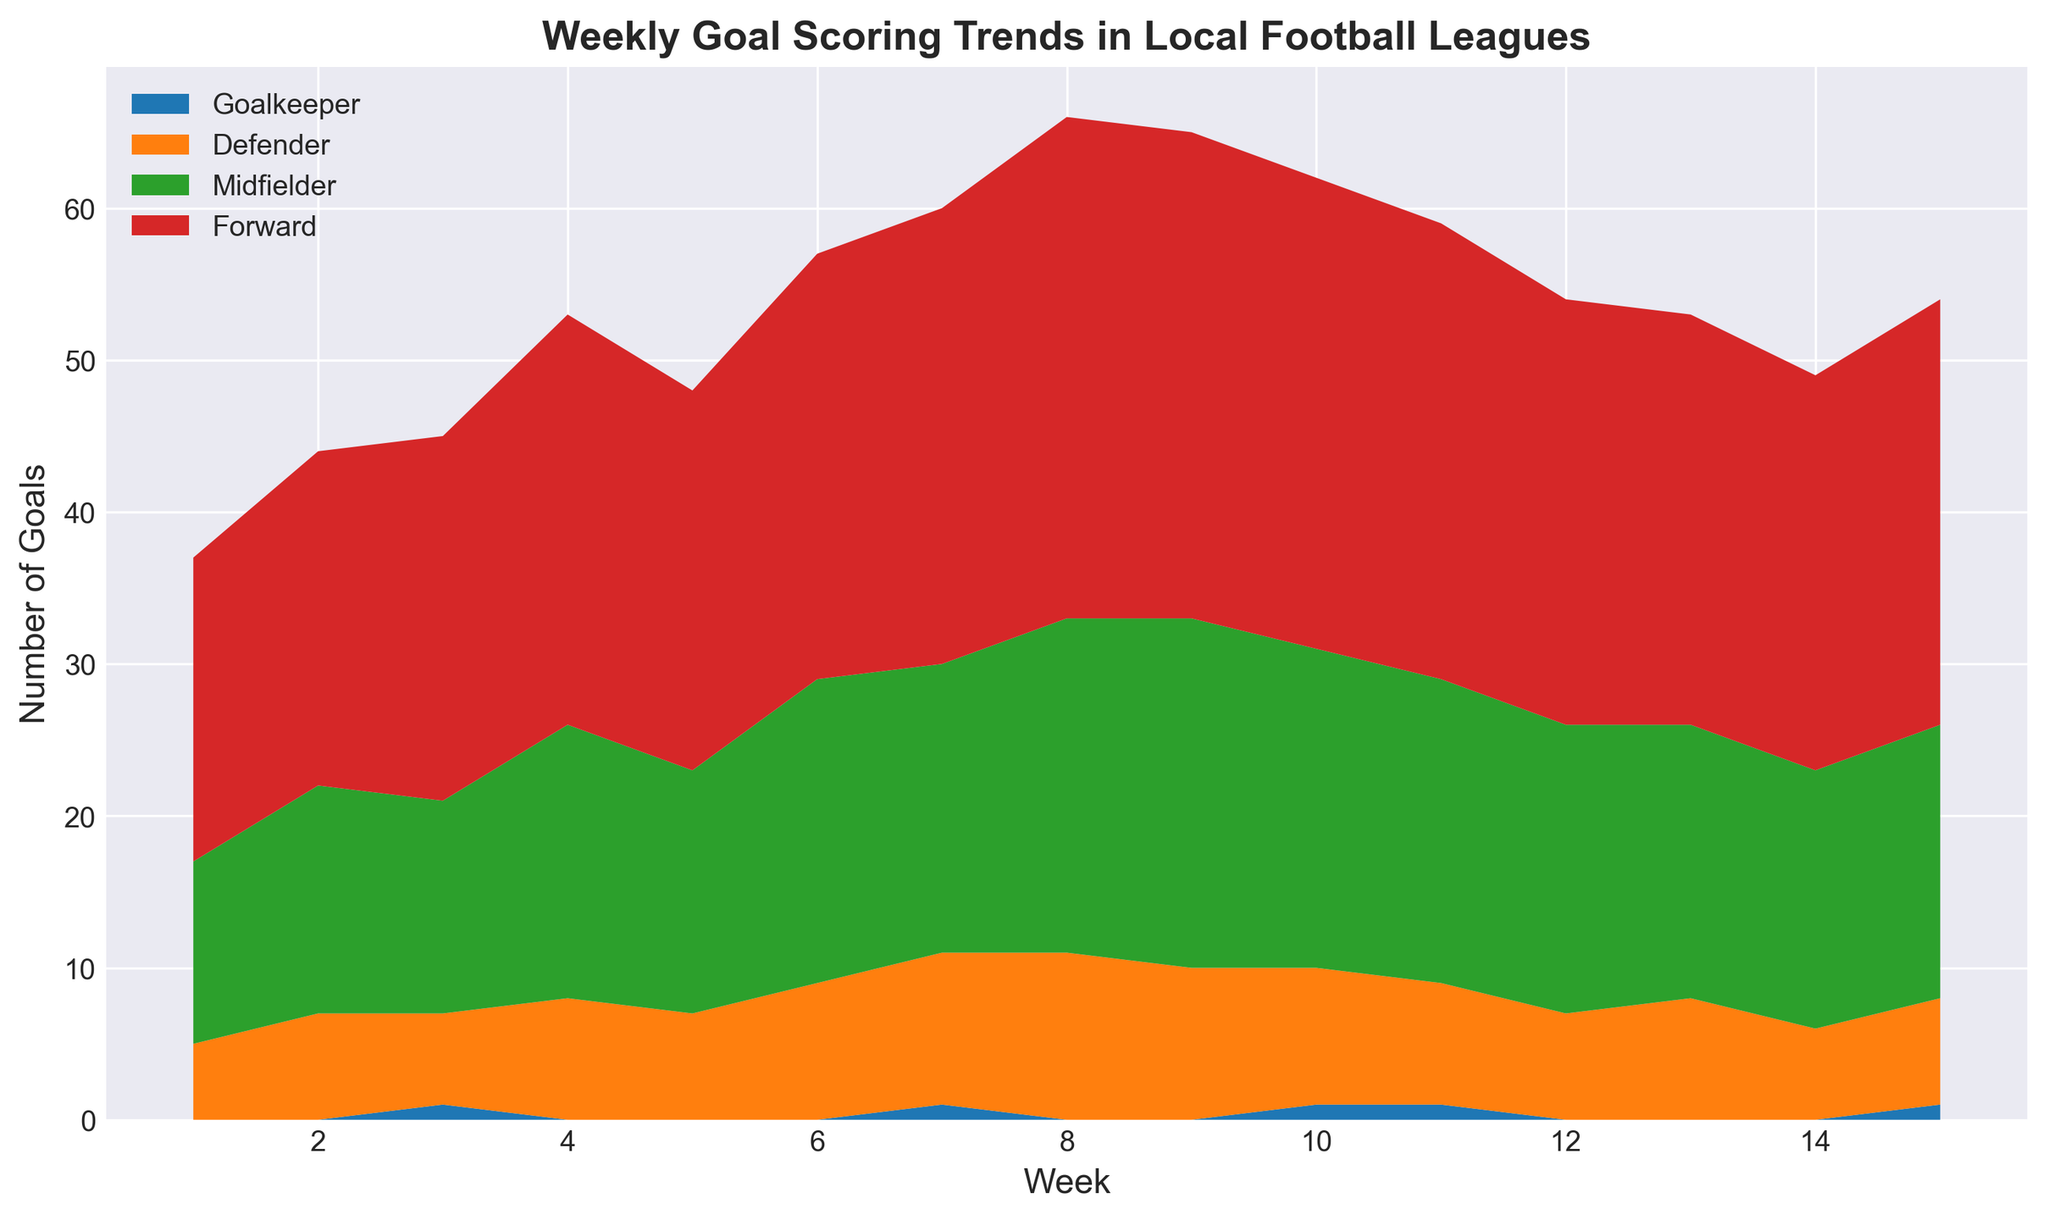How many total goals were scored by Midfielders over the 15 weeks? Sum the goals scored by Midfielders each week: 12 + 15 + 14 + 18 + 16 + 20 + 19 + 22 + 23 + 21 + 20 + 19 + 18 + 17 + 18 = 272
Answer: 272 In which week did the Defenders score the highest number of goals? Analyze the data for Defenders in each week and identify the highest value. Week 8 has the highest value of 11 goals.
Answer: Week 8 Which position saw the most consistent goal-scoring trend? From the chart, Midfielders show a steady trend in goal scoring with fewer large fluctuations compared to other positions.
Answer: Midfielder What is the total difference in goals scored between Forwards and Defenders in Week 7? Subtract the goals scored by Defenders from those scored by Forwards in Week 7: 30 - 10 = 20
Answer: 20 In Week 4, how many total goals were scored by all positions combined? Sum the goals scored by all positions in Week 4: 0 (Goalkeeper) + 8 (Defender) + 18 (Midfielder) + 27 (Forward) = 53
Answer: 53 Which position scored the fewest goals overall? By summing each position's total goals: 
Goalkeeper: 4
Defender: 118
Midfielder: 269
Forward: 403 
Goalkeepers scored the fewest goals overall.
Answer: Goalkeeper Which two consecutive weeks show the largest increase in total goals scored by all positions? Calculate the total goals for each week and find the difference between consecutive weeks. The largest increase is between Week 7 (60 goals) and Week 8 (66 goals), an increase of 6 goals.
Answer: Week 7 to 8 On average, how many goals did Forwards score per week? Sum the total goals scored by Forwards in 15 weeks: 20 + 22 + 24 + 27 + 25 + 28 + 30 + 33 + 32 + 31 + 30 + 28 + 27 + 26 + 28 = 409, then divide by 15 (weeks): 409 / 15 ≈ 27.27
Answer: 27.27 Which week has the lowest total number of goals scored? Calculate the total goals for each week and identify the week with the smallest total. Week 1 has the lowest total number of goals (37).
Answer: Week 1 